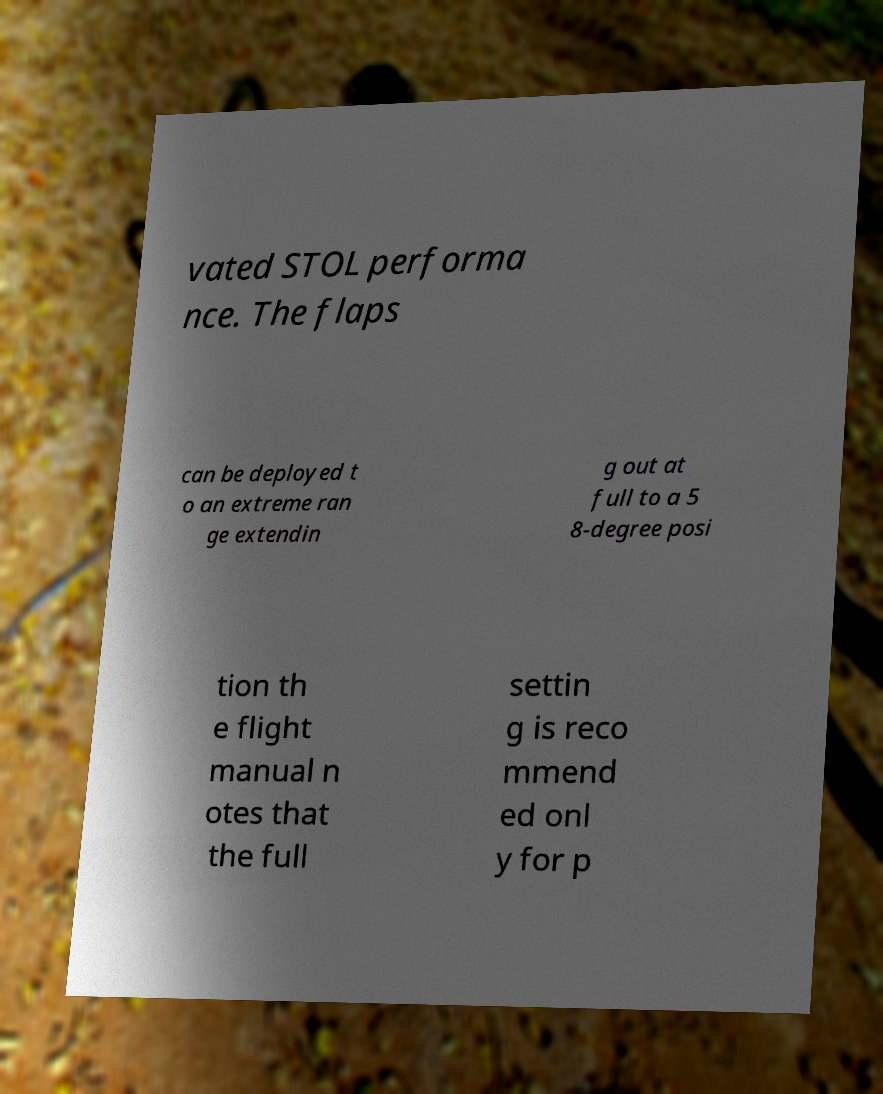There's text embedded in this image that I need extracted. Can you transcribe it verbatim? vated STOL performa nce. The flaps can be deployed t o an extreme ran ge extendin g out at full to a 5 8-degree posi tion th e flight manual n otes that the full settin g is reco mmend ed onl y for p 